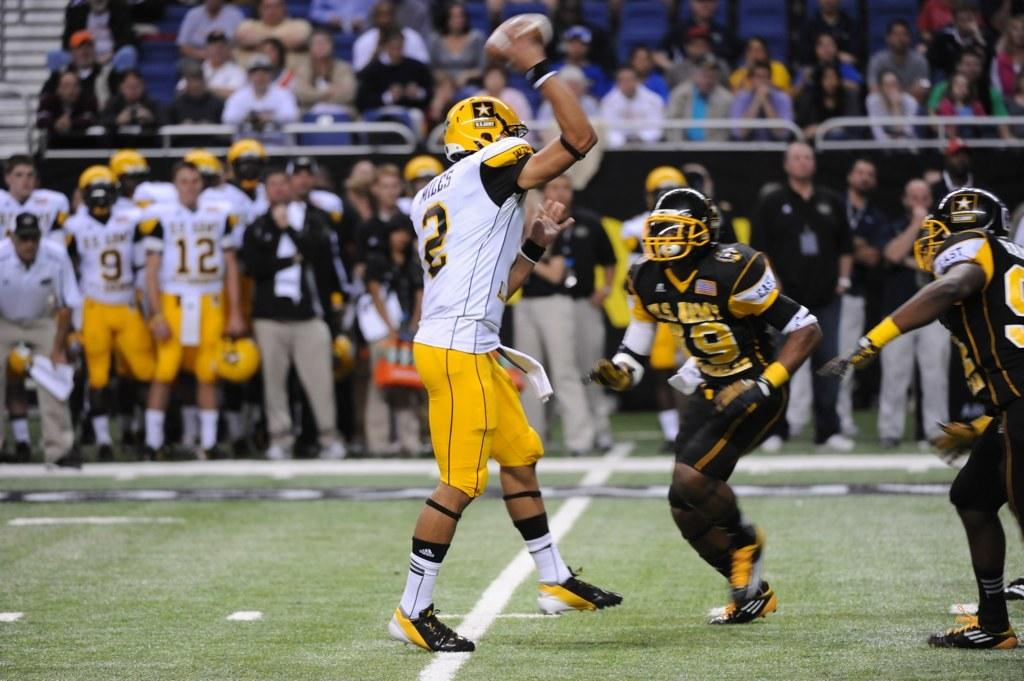What are the people in the image doing? There are groups of people standing and people sitting on chairs in the image. Can you describe the activity or event taking place in the image? A person is holding a ball in their hand, which suggests a possible game or activity involving the ball. Where is the image likely to be taken? The setting appears to be on a ground or similar open area. What type of office furniture can be seen in the image? There is no office furniture present in the image; it features people standing, sitting, and holding a ball in an open area. Can you spot any rabbits in the image? There are no rabbits visible in the image. 